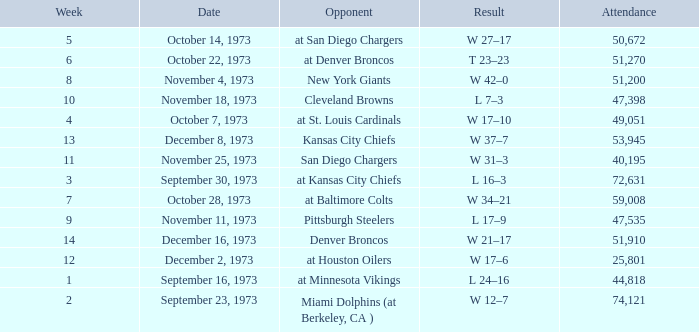What is the result later than week 13? W 21–17. 